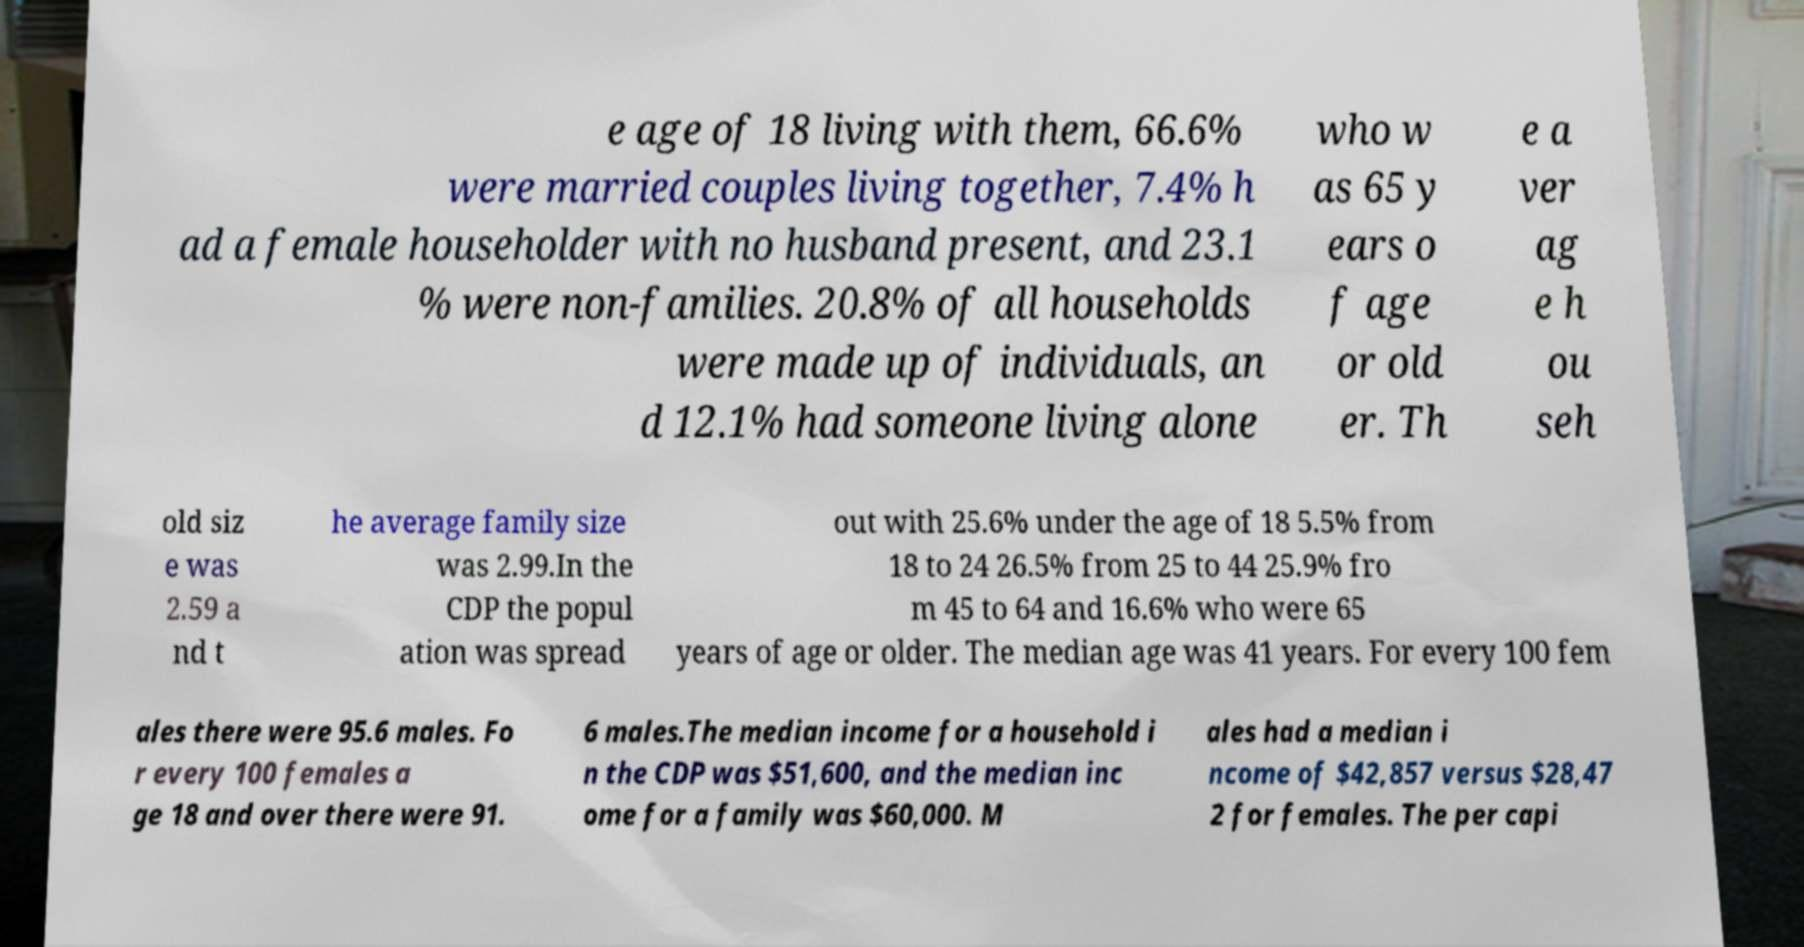Please read and relay the text visible in this image. What does it say? e age of 18 living with them, 66.6% were married couples living together, 7.4% h ad a female householder with no husband present, and 23.1 % were non-families. 20.8% of all households were made up of individuals, an d 12.1% had someone living alone who w as 65 y ears o f age or old er. Th e a ver ag e h ou seh old siz e was 2.59 a nd t he average family size was 2.99.In the CDP the popul ation was spread out with 25.6% under the age of 18 5.5% from 18 to 24 26.5% from 25 to 44 25.9% fro m 45 to 64 and 16.6% who were 65 years of age or older. The median age was 41 years. For every 100 fem ales there were 95.6 males. Fo r every 100 females a ge 18 and over there were 91. 6 males.The median income for a household i n the CDP was $51,600, and the median inc ome for a family was $60,000. M ales had a median i ncome of $42,857 versus $28,47 2 for females. The per capi 